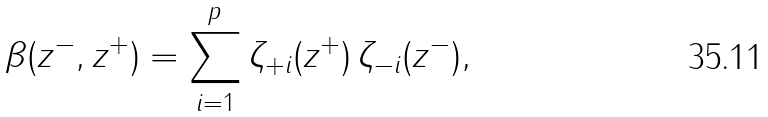<formula> <loc_0><loc_0><loc_500><loc_500>\beta ( z ^ { - } , z ^ { + } ) = \sum _ { i = 1 } ^ { p } \zeta _ { + i } ( z ^ { + } ) \, \zeta _ { - i } ( z ^ { - } ) ,</formula> 